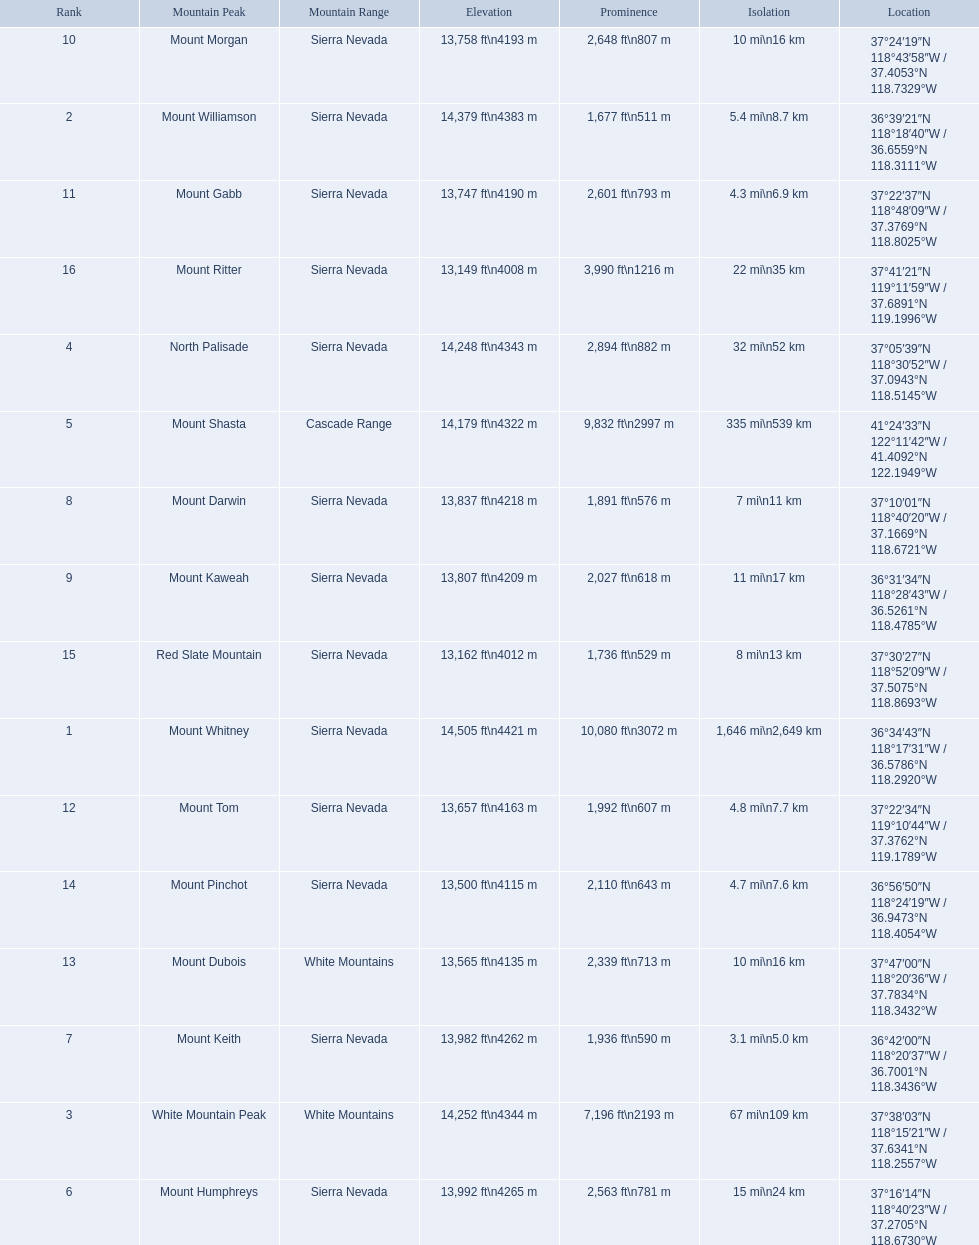What are the listed elevations? 14,505 ft\n4421 m, 14,379 ft\n4383 m, 14,252 ft\n4344 m, 14,248 ft\n4343 m, 14,179 ft\n4322 m, 13,992 ft\n4265 m, 13,982 ft\n4262 m, 13,837 ft\n4218 m, 13,807 ft\n4209 m, 13,758 ft\n4193 m, 13,747 ft\n4190 m, 13,657 ft\n4163 m, 13,565 ft\n4135 m, 13,500 ft\n4115 m, 13,162 ft\n4012 m, 13,149 ft\n4008 m. Which of those is 13,149 ft or below? 13,149 ft\n4008 m. To what mountain peak does that value correspond? Mount Ritter. 